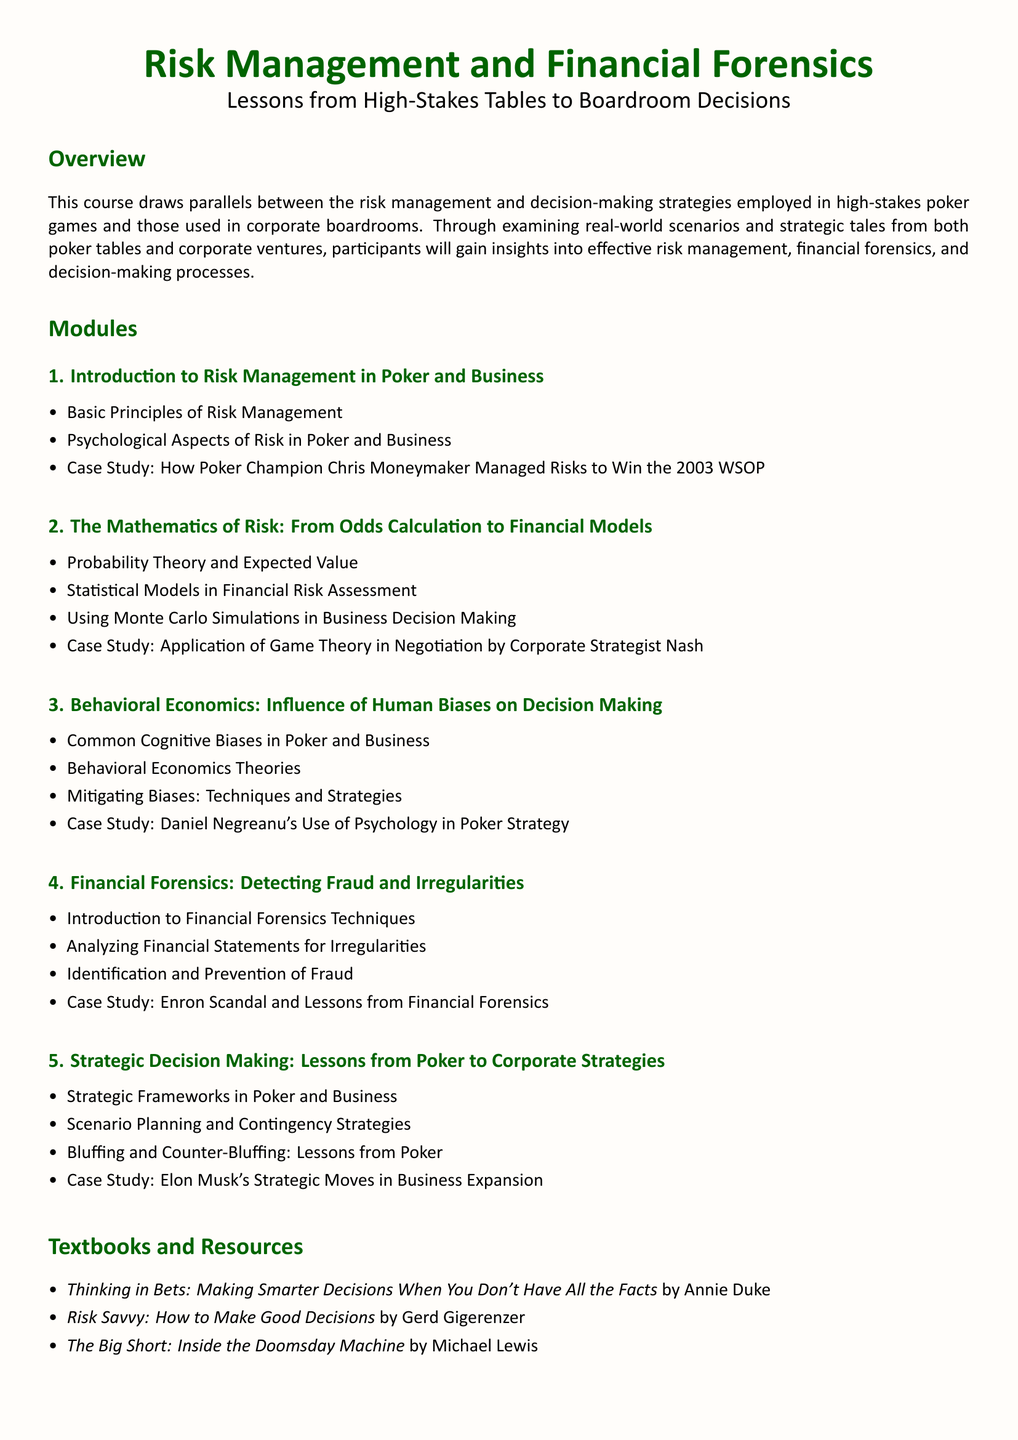What is the main theme of the course? The main theme of the course is the parallels between risk management and decision-making strategies in poker and corporate settings.
Answer: Risk management and decision-making in poker and corporate settings What is the title of the first module? The title of the first module is stated at the beginning of the respective section in the document.
Answer: Introduction to Risk Management in Poker and Business Who is the poker champion mentioned in the first module? The document specifically mentions Chris Moneymaker in relation to risk management.
Answer: Chris Moneymaker What mathematical concept is introduced in the second module? The second module introduces probability theory as a key mathematical concept related to risk.
Answer: Probability Theory What case study is referenced in the third module? The case study focuses on Daniel Negreanu and his strategic use of psychology.
Answer: Daniel Negreanu's Use of Psychology in Poker Strategy Which scandal is discussed in the fourth module? The fourth module discusses a notorious corporate scandal to illustrate financial forensics.
Answer: Enron Scandal What is a key textbook listed in the resources? The documents include various textbooks, with specific titles listed under resources, such as a work by Annie Duke.
Answer: Thinking in Bets: Making Smarter Decisions When You Don't Have All the Facts What is the focus of the final module? The final module emphasizes strategic decision-making lessons derived from poker for corporate strategy formulation.
Answer: Strategic Decision Making: Lessons from Poker to Corporate Strategies 